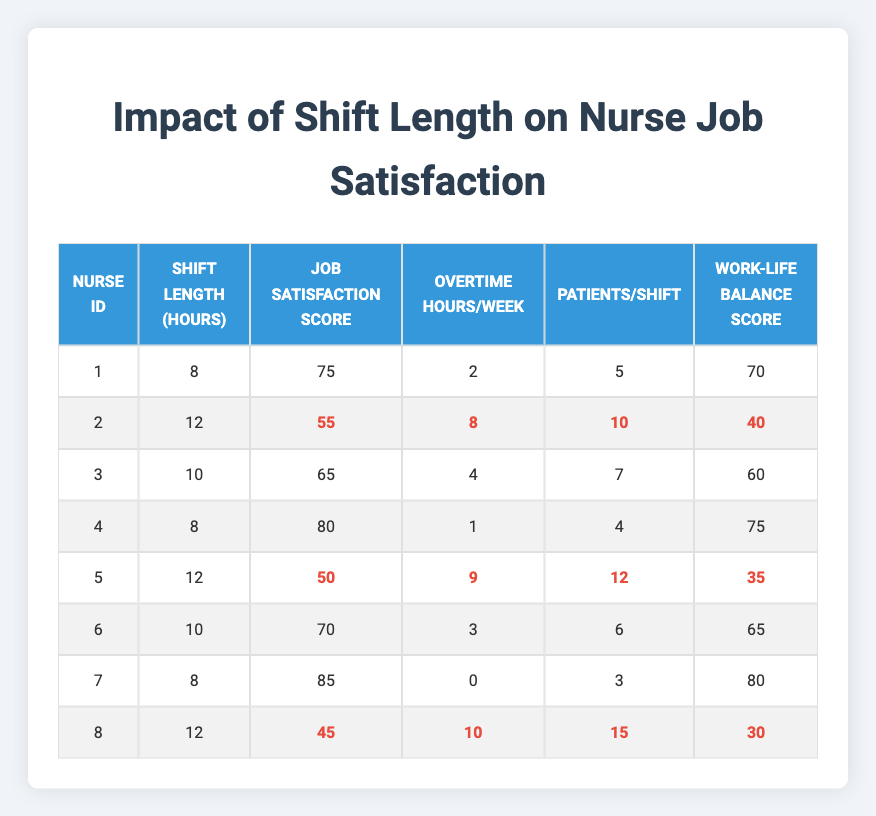What's the job satisfaction score of Nurse ID 4? The table lists Nurse ID 4's job satisfaction score directly under the relevant column. It states a score of 80.
Answer: 80 What is the shift length for the nurse with the lowest job satisfaction score? Looking through the job satisfaction scores, Nurse ID 8 has the lowest score of 45, which is associated with a shift length of 12 hours.
Answer: 12 How many nurses have a shift length of 10 hours? By inspecting the table, there are two entries for nurses with a shift length of 10 hours (Nurse ID 3 and Nurse ID 6). Therefore, the count is 2.
Answer: 2 What is the average job satisfaction score for nurses who work 12-hour shifts? The job satisfaction scores for the two nurses with 12-hour shifts (Nurse ID 2 and Nurse ID 5) are 55 and 50 respectively. Adding these scores gives 105, and dividing by 2 gives an average of 52.5.
Answer: 52.5 Is there a nurse who has both a score of 80 or above for job satisfaction and works an 8-hour shift? Scanning the table, Nurse ID 4 has a job satisfaction score of 80 and works an 8-hour shift, confirming that there is at least one nurse who meets this criterion.
Answer: Yes What is the total number of overtime hours for all nurses who have a work-life balance score of 70 or higher? First, identify the nurses with a work-life balance score of 70 or higher: Nurse ID 1, 4, 6, and 7. Their corresponding overtime hours are 2, 1, 3, and 0, respectively, which sums up to 6 hours.
Answer: 6 What is the difference between the job satisfaction scores of nurses who work 8 hours versus those who work 12 hours? The job satisfaction scores for 8-hour shift nurses (75, 80, 85) average to 80, while those for 12-hour shift nurses (55, 50) average to 52.5. The difference is 80 - 52.5 = 27.5.
Answer: 27.5 Was there any nurse who had to handle more than 10 patients per shift and also had a job satisfaction score lower than 50? Upon reviewing the data, Nurse ID 8 had 15 patients per shift and a job satisfaction score of 45, confirming that such a nurse exists.
Answer: Yes 